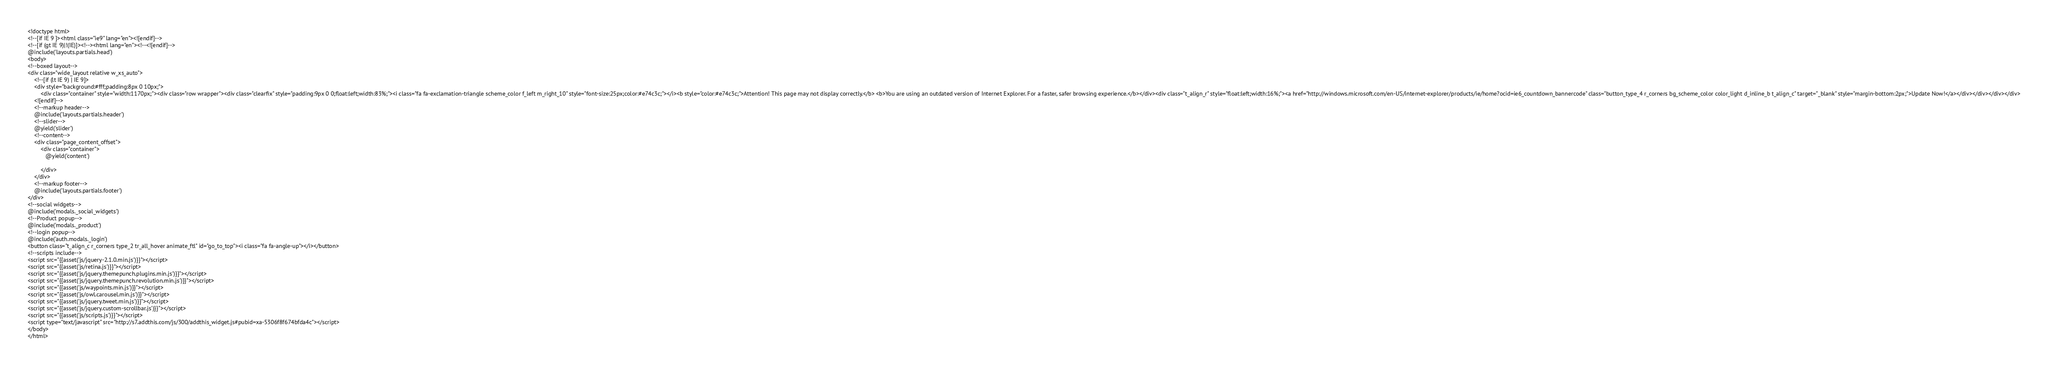Convert code to text. <code><loc_0><loc_0><loc_500><loc_500><_PHP_><!doctype html>
<!--[if IE 9 ]><html class="ie9" lang="en"><![endif]-->
<!--[if (gt IE 9)|!(IE)]><!--><html lang="en"><!--<![endif]-->
@include('layouts.partials.head')
<body>
<!--boxed layout-->
<div class="wide_layout relative w_xs_auto">
    <!--[if (lt IE 9) | IE 9]>
    <div style="background:#fff;padding:8px 0 10px;">
        <div class="container" style="width:1170px;"><div class="row wrapper"><div class="clearfix" style="padding:9px 0 0;float:left;width:83%;"><i class="fa fa-exclamation-triangle scheme_color f_left m_right_10" style="font-size:25px;color:#e74c3c;"></i><b style="color:#e74c3c;">Attention! This page may not display correctly.</b> <b>You are using an outdated version of Internet Explorer. For a faster, safer browsing experience.</b></div><div class="t_align_r" style="float:left;width:16%;"><a href="http://windows.microsoft.com/en-US/internet-explorer/products/ie/home?ocid=ie6_countdown_bannercode" class="button_type_4 r_corners bg_scheme_color color_light d_inline_b t_align_c" target="_blank" style="margin-bottom:2px;">Update Now!</a></div></div></div></div>
    <![endif]-->
    <!--markup header-->
    @include('layouts.partials.header')
    <!--slider-->
    @yield('slider')
    <!--content-->
    <div class="page_content_offset">
        <div class="container">
           @yield('content')

        </div>
    </div>
    <!--markup footer-->
    @include('layouts.partials.footer')
</div>
<!--social widgets-->
@include('modals._social_widgets')
<!--Product popup-->
@include('modals._product')
<!--login popup-->
@include('auth.modals._login')
<button class="t_align_c r_corners type_2 tr_all_hover animate_ftl" id="go_to_top"><i class="fa fa-angle-up"></i></button>
<!--scripts include-->
<script src="{{asset('js/jquery-2.1.0.min.js')}}"></script>
<script src="{{asset('js/retina.js')}}"></script>
<script src="{{asset('js/jquery.themepunch.plugins.min.js')}}"></script>
<script src="{{asset('js/jquery.themepunch.revolution.min.js')}}"></script>
<script src="{{asset('js/waypoints.min.js')}}"></script>
<script src="{{asset('js/owl.carousel.min.js')}}"></script>
<script src="{{asset('js/jquery.tweet.min.js')}}"></script>
<script src="{{asset('js/jquery.custom-scrollbar.js')}}"></script>
<script src="{{asset('js/scripts.js')}}"></script>
<script type="text/javascript" src="http://s7.addthis.com/js/300/addthis_widget.js#pubid=xa-5306f8f674bfda4c"></script>
</body>
</html></code> 